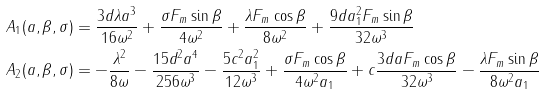<formula> <loc_0><loc_0><loc_500><loc_500>& A _ { 1 } ( a , \beta , \sigma ) = \frac { 3 d \lambda a ^ { 3 } } { 1 6 \omega ^ { 2 } } + \frac { \sigma F _ { m } \sin \beta } { 4 \omega ^ { 2 } } + \frac { \lambda F _ { m } \cos \beta } { 8 \omega ^ { 2 } } + \frac { 9 d a _ { 1 } ^ { 2 } F _ { m } \sin \beta } { 3 2 \omega ^ { 3 } } \\ & A _ { 2 } ( a , \beta , \sigma ) = - \frac { \lambda ^ { 2 } } { 8 \omega } - \frac { 1 5 d ^ { 2 } a ^ { 4 } } { 2 5 6 \omega ^ { 3 } } - \frac { 5 c ^ { 2 } a _ { 1 } ^ { 2 } } { 1 2 \omega ^ { 3 } } + \frac { \sigma F _ { m } \cos \beta } { 4 \omega ^ { 2 } a _ { 1 } } + c \frac { 3 d a F _ { m } \cos \beta } { 3 2 \omega ^ { 3 } } - \frac { \lambda F _ { m } \sin \beta } { 8 \omega ^ { 2 } a _ { 1 } }</formula> 